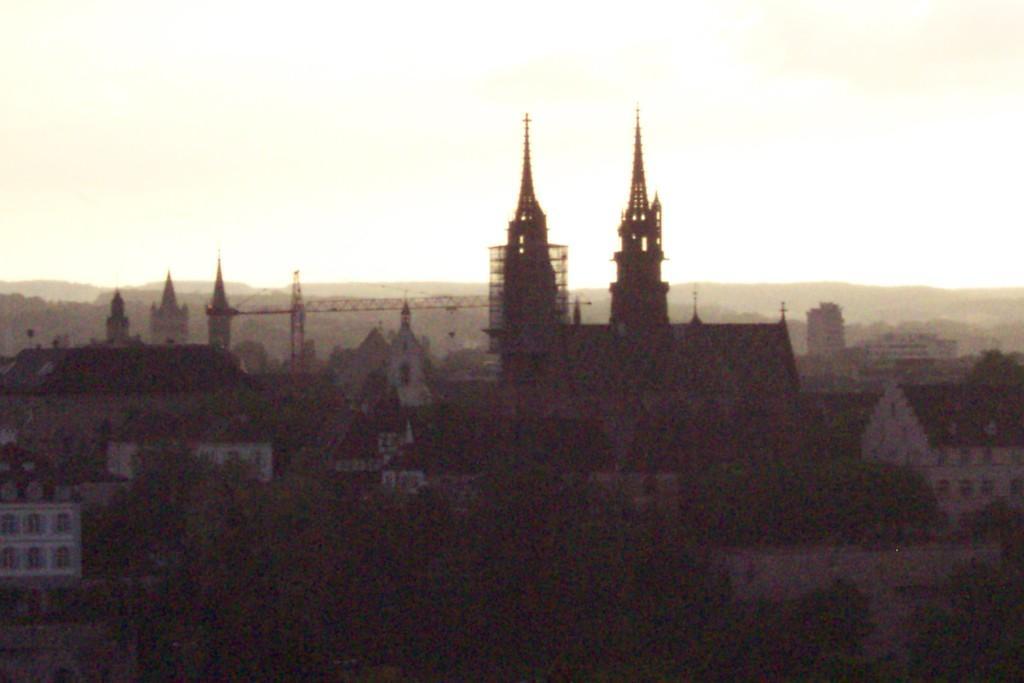How would you summarize this image in a sentence or two? In this image I can see the dark picture in which I can see number of buildings, few trees, few cranes and in the background I can see the sky. 